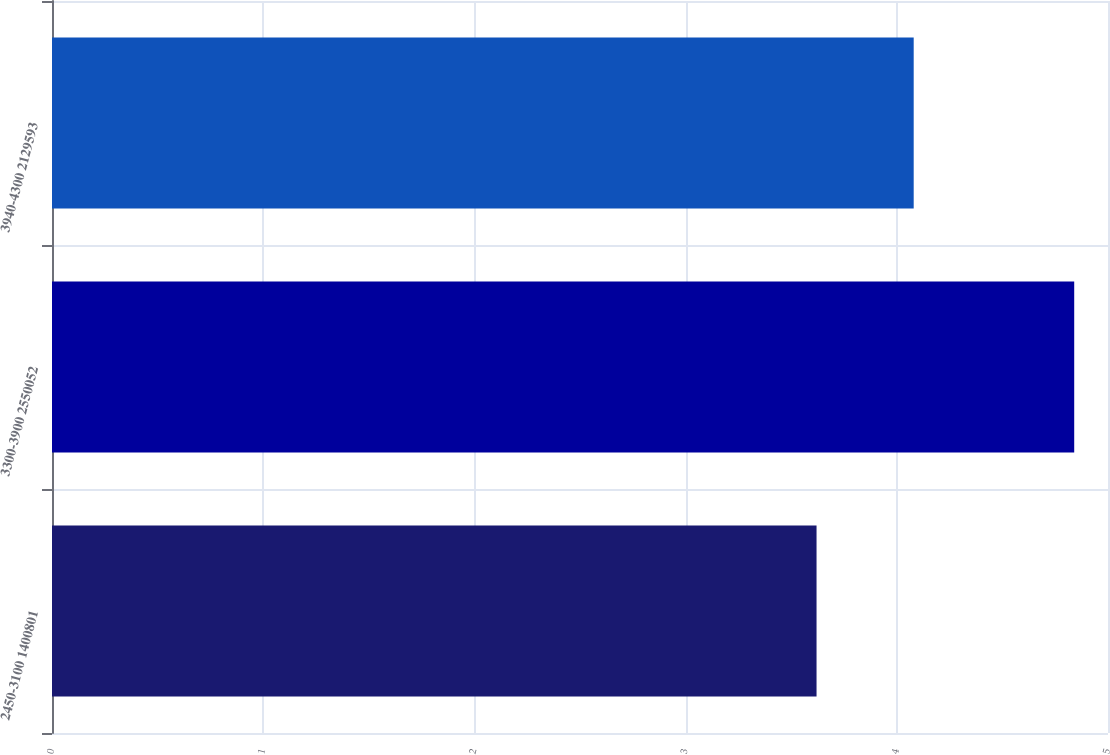<chart> <loc_0><loc_0><loc_500><loc_500><bar_chart><fcel>2450-3100 1400801<fcel>3300-3900 2550052<fcel>3940-4300 2129593<nl><fcel>3.62<fcel>4.84<fcel>4.08<nl></chart> 